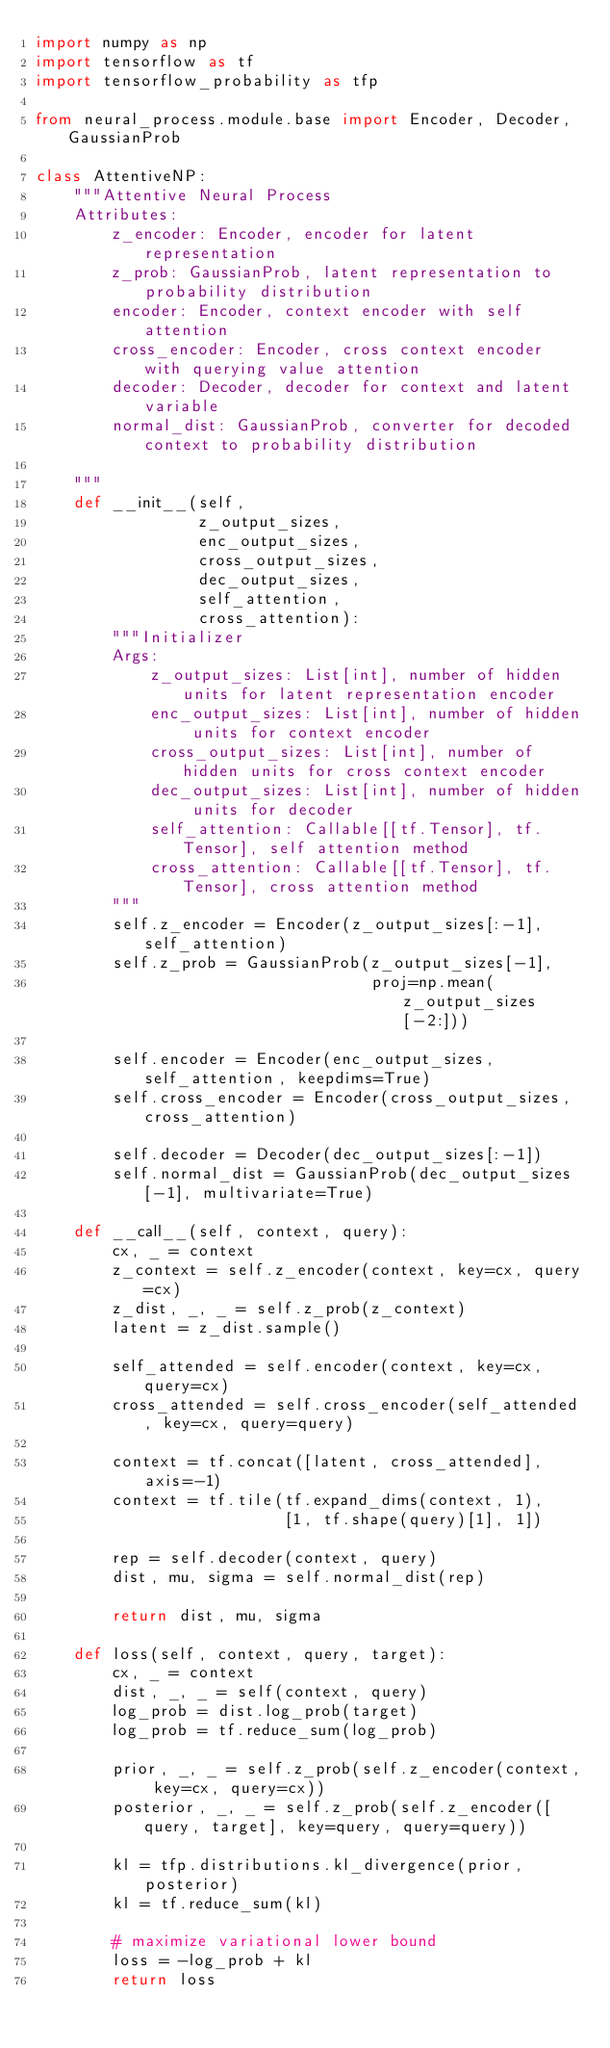<code> <loc_0><loc_0><loc_500><loc_500><_Python_>import numpy as np
import tensorflow as tf
import tensorflow_probability as tfp

from neural_process.module.base import Encoder, Decoder, GaussianProb

class AttentiveNP:
    """Attentive Neural Process
    Attributes:
        z_encoder: Encoder, encoder for latent representation
        z_prob: GaussianProb, latent representation to probability distribution
        encoder: Encoder, context encoder with self attention
        cross_encoder: Encoder, cross context encoder with querying value attention
        decoder: Decoder, decoder for context and latent variable
        normal_dist: GaussianProb, converter for decoded context to probability distribution

    """
    def __init__(self,
                 z_output_sizes,
                 enc_output_sizes,
                 cross_output_sizes,
                 dec_output_sizes,
                 self_attention,
                 cross_attention):
        """Initializer
        Args:
            z_output_sizes: List[int], number of hidden units for latent representation encoder
            enc_output_sizes: List[int], number of hidden units for context encoder
            cross_output_sizes: List[int], number of hidden units for cross context encoder
            dec_output_sizes: List[int], number of hidden units for decoder
            self_attention: Callable[[tf.Tensor], tf.Tensor], self attention method
            cross_attention: Callable[[tf.Tensor], tf.Tensor], cross attention method
        """
        self.z_encoder = Encoder(z_output_sizes[:-1], self_attention)
        self.z_prob = GaussianProb(z_output_sizes[-1],
                                   proj=np.mean(z_output_sizes[-2:]))

        self.encoder = Encoder(enc_output_sizes, self_attention, keepdims=True)
        self.cross_encoder = Encoder(cross_output_sizes, cross_attention)

        self.decoder = Decoder(dec_output_sizes[:-1])
        self.normal_dist = GaussianProb(dec_output_sizes[-1], multivariate=True)

    def __call__(self, context, query):
        cx, _ = context
        z_context = self.z_encoder(context, key=cx, query=cx)
        z_dist, _, _ = self.z_prob(z_context)
        latent = z_dist.sample()

        self_attended = self.encoder(context, key=cx, query=cx)
        cross_attended = self.cross_encoder(self_attended, key=cx, query=query)

        context = tf.concat([latent, cross_attended], axis=-1)
        context = tf.tile(tf.expand_dims(context, 1),
                          [1, tf.shape(query)[1], 1])

        rep = self.decoder(context, query)
        dist, mu, sigma = self.normal_dist(rep)

        return dist, mu, sigma

    def loss(self, context, query, target):
        cx, _ = context
        dist, _, _ = self(context, query)
        log_prob = dist.log_prob(target)
        log_prob = tf.reduce_sum(log_prob)

        prior, _, _ = self.z_prob(self.z_encoder(context, key=cx, query=cx))
        posterior, _, _ = self.z_prob(self.z_encoder([query, target], key=query, query=query))

        kl = tfp.distributions.kl_divergence(prior, posterior)
        kl = tf.reduce_sum(kl)

        # maximize variational lower bound
        loss = -log_prob + kl
        return loss
</code> 